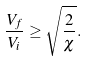<formula> <loc_0><loc_0><loc_500><loc_500>\frac { V _ { f } } { V _ { i } } \geq \sqrt { \frac { 2 } { \chi } } .</formula> 